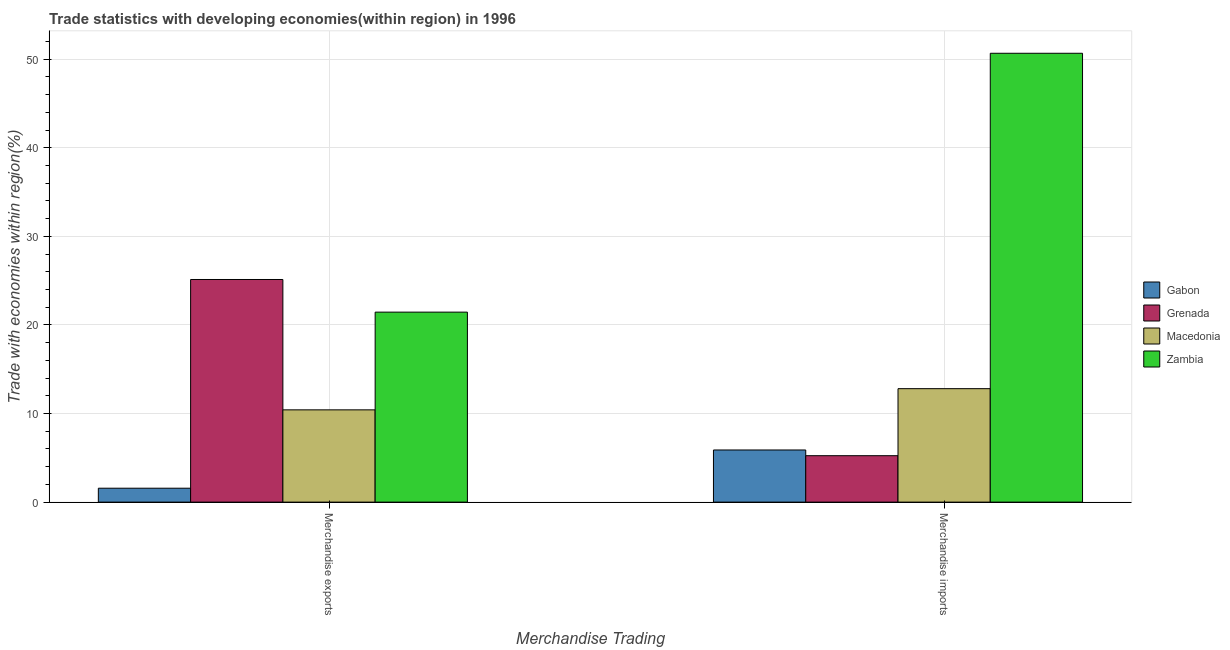How many different coloured bars are there?
Your answer should be compact. 4. Are the number of bars on each tick of the X-axis equal?
Provide a short and direct response. Yes. What is the label of the 2nd group of bars from the left?
Ensure brevity in your answer.  Merchandise imports. What is the merchandise imports in Gabon?
Your answer should be very brief. 5.89. Across all countries, what is the maximum merchandise imports?
Ensure brevity in your answer.  50.67. Across all countries, what is the minimum merchandise exports?
Provide a short and direct response. 1.57. In which country was the merchandise imports maximum?
Make the answer very short. Zambia. In which country was the merchandise imports minimum?
Your response must be concise. Grenada. What is the total merchandise exports in the graph?
Your response must be concise. 58.56. What is the difference between the merchandise imports in Macedonia and that in Gabon?
Provide a short and direct response. 6.92. What is the difference between the merchandise imports in Gabon and the merchandise exports in Macedonia?
Offer a very short reply. -4.53. What is the average merchandise exports per country?
Your answer should be very brief. 14.64. What is the difference between the merchandise exports and merchandise imports in Gabon?
Keep it short and to the point. -4.32. What is the ratio of the merchandise exports in Grenada to that in Zambia?
Provide a succinct answer. 1.17. Is the merchandise imports in Zambia less than that in Gabon?
Your answer should be very brief. No. What does the 4th bar from the left in Merchandise exports represents?
Ensure brevity in your answer.  Zambia. What does the 4th bar from the right in Merchandise exports represents?
Provide a succinct answer. Gabon. How many bars are there?
Offer a very short reply. 8. Are all the bars in the graph horizontal?
Offer a very short reply. No. How many countries are there in the graph?
Provide a succinct answer. 4. Are the values on the major ticks of Y-axis written in scientific E-notation?
Offer a terse response. No. Does the graph contain grids?
Offer a very short reply. Yes. Where does the legend appear in the graph?
Provide a short and direct response. Center right. How many legend labels are there?
Your answer should be compact. 4. How are the legend labels stacked?
Give a very brief answer. Vertical. What is the title of the graph?
Your response must be concise. Trade statistics with developing economies(within region) in 1996. What is the label or title of the X-axis?
Keep it short and to the point. Merchandise Trading. What is the label or title of the Y-axis?
Make the answer very short. Trade with economies within region(%). What is the Trade with economies within region(%) in Gabon in Merchandise exports?
Provide a short and direct response. 1.57. What is the Trade with economies within region(%) in Grenada in Merchandise exports?
Offer a very short reply. 25.13. What is the Trade with economies within region(%) in Macedonia in Merchandise exports?
Offer a very short reply. 10.42. What is the Trade with economies within region(%) in Zambia in Merchandise exports?
Offer a terse response. 21.45. What is the Trade with economies within region(%) in Gabon in Merchandise imports?
Offer a very short reply. 5.89. What is the Trade with economies within region(%) in Grenada in Merchandise imports?
Your response must be concise. 5.24. What is the Trade with economies within region(%) in Macedonia in Merchandise imports?
Keep it short and to the point. 12.81. What is the Trade with economies within region(%) of Zambia in Merchandise imports?
Ensure brevity in your answer.  50.67. Across all Merchandise Trading, what is the maximum Trade with economies within region(%) in Gabon?
Your answer should be compact. 5.89. Across all Merchandise Trading, what is the maximum Trade with economies within region(%) of Grenada?
Your answer should be compact. 25.13. Across all Merchandise Trading, what is the maximum Trade with economies within region(%) in Macedonia?
Give a very brief answer. 12.81. Across all Merchandise Trading, what is the maximum Trade with economies within region(%) of Zambia?
Offer a terse response. 50.67. Across all Merchandise Trading, what is the minimum Trade with economies within region(%) in Gabon?
Offer a terse response. 1.57. Across all Merchandise Trading, what is the minimum Trade with economies within region(%) in Grenada?
Keep it short and to the point. 5.24. Across all Merchandise Trading, what is the minimum Trade with economies within region(%) of Macedonia?
Your answer should be compact. 10.42. Across all Merchandise Trading, what is the minimum Trade with economies within region(%) of Zambia?
Your answer should be compact. 21.45. What is the total Trade with economies within region(%) of Gabon in the graph?
Offer a terse response. 7.46. What is the total Trade with economies within region(%) in Grenada in the graph?
Offer a very short reply. 30.37. What is the total Trade with economies within region(%) in Macedonia in the graph?
Make the answer very short. 23.22. What is the total Trade with economies within region(%) in Zambia in the graph?
Your answer should be compact. 72.11. What is the difference between the Trade with economies within region(%) in Gabon in Merchandise exports and that in Merchandise imports?
Your answer should be very brief. -4.32. What is the difference between the Trade with economies within region(%) in Grenada in Merchandise exports and that in Merchandise imports?
Your response must be concise. 19.89. What is the difference between the Trade with economies within region(%) of Macedonia in Merchandise exports and that in Merchandise imports?
Keep it short and to the point. -2.39. What is the difference between the Trade with economies within region(%) of Zambia in Merchandise exports and that in Merchandise imports?
Provide a succinct answer. -29.22. What is the difference between the Trade with economies within region(%) in Gabon in Merchandise exports and the Trade with economies within region(%) in Grenada in Merchandise imports?
Ensure brevity in your answer.  -3.67. What is the difference between the Trade with economies within region(%) in Gabon in Merchandise exports and the Trade with economies within region(%) in Macedonia in Merchandise imports?
Offer a very short reply. -11.24. What is the difference between the Trade with economies within region(%) in Gabon in Merchandise exports and the Trade with economies within region(%) in Zambia in Merchandise imports?
Give a very brief answer. -49.1. What is the difference between the Trade with economies within region(%) of Grenada in Merchandise exports and the Trade with economies within region(%) of Macedonia in Merchandise imports?
Give a very brief answer. 12.32. What is the difference between the Trade with economies within region(%) of Grenada in Merchandise exports and the Trade with economies within region(%) of Zambia in Merchandise imports?
Provide a short and direct response. -25.54. What is the difference between the Trade with economies within region(%) in Macedonia in Merchandise exports and the Trade with economies within region(%) in Zambia in Merchandise imports?
Your answer should be very brief. -40.25. What is the average Trade with economies within region(%) in Gabon per Merchandise Trading?
Your answer should be compact. 3.73. What is the average Trade with economies within region(%) of Grenada per Merchandise Trading?
Keep it short and to the point. 15.19. What is the average Trade with economies within region(%) in Macedonia per Merchandise Trading?
Ensure brevity in your answer.  11.61. What is the average Trade with economies within region(%) of Zambia per Merchandise Trading?
Give a very brief answer. 36.06. What is the difference between the Trade with economies within region(%) in Gabon and Trade with economies within region(%) in Grenada in Merchandise exports?
Keep it short and to the point. -23.56. What is the difference between the Trade with economies within region(%) of Gabon and Trade with economies within region(%) of Macedonia in Merchandise exports?
Provide a short and direct response. -8.85. What is the difference between the Trade with economies within region(%) of Gabon and Trade with economies within region(%) of Zambia in Merchandise exports?
Provide a succinct answer. -19.88. What is the difference between the Trade with economies within region(%) of Grenada and Trade with economies within region(%) of Macedonia in Merchandise exports?
Your answer should be very brief. 14.72. What is the difference between the Trade with economies within region(%) of Grenada and Trade with economies within region(%) of Zambia in Merchandise exports?
Your answer should be compact. 3.68. What is the difference between the Trade with economies within region(%) of Macedonia and Trade with economies within region(%) of Zambia in Merchandise exports?
Offer a terse response. -11.03. What is the difference between the Trade with economies within region(%) of Gabon and Trade with economies within region(%) of Grenada in Merchandise imports?
Your answer should be compact. 0.65. What is the difference between the Trade with economies within region(%) of Gabon and Trade with economies within region(%) of Macedonia in Merchandise imports?
Provide a succinct answer. -6.92. What is the difference between the Trade with economies within region(%) of Gabon and Trade with economies within region(%) of Zambia in Merchandise imports?
Your answer should be very brief. -44.78. What is the difference between the Trade with economies within region(%) in Grenada and Trade with economies within region(%) in Macedonia in Merchandise imports?
Your answer should be compact. -7.57. What is the difference between the Trade with economies within region(%) of Grenada and Trade with economies within region(%) of Zambia in Merchandise imports?
Provide a short and direct response. -45.43. What is the difference between the Trade with economies within region(%) of Macedonia and Trade with economies within region(%) of Zambia in Merchandise imports?
Offer a terse response. -37.86. What is the ratio of the Trade with economies within region(%) in Gabon in Merchandise exports to that in Merchandise imports?
Your response must be concise. 0.27. What is the ratio of the Trade with economies within region(%) in Grenada in Merchandise exports to that in Merchandise imports?
Your answer should be compact. 4.8. What is the ratio of the Trade with economies within region(%) of Macedonia in Merchandise exports to that in Merchandise imports?
Your answer should be very brief. 0.81. What is the ratio of the Trade with economies within region(%) in Zambia in Merchandise exports to that in Merchandise imports?
Provide a succinct answer. 0.42. What is the difference between the highest and the second highest Trade with economies within region(%) of Gabon?
Your answer should be very brief. 4.32. What is the difference between the highest and the second highest Trade with economies within region(%) in Grenada?
Keep it short and to the point. 19.89. What is the difference between the highest and the second highest Trade with economies within region(%) in Macedonia?
Provide a succinct answer. 2.39. What is the difference between the highest and the second highest Trade with economies within region(%) of Zambia?
Keep it short and to the point. 29.22. What is the difference between the highest and the lowest Trade with economies within region(%) in Gabon?
Your answer should be very brief. 4.32. What is the difference between the highest and the lowest Trade with economies within region(%) of Grenada?
Your answer should be compact. 19.89. What is the difference between the highest and the lowest Trade with economies within region(%) in Macedonia?
Offer a very short reply. 2.39. What is the difference between the highest and the lowest Trade with economies within region(%) of Zambia?
Provide a short and direct response. 29.22. 